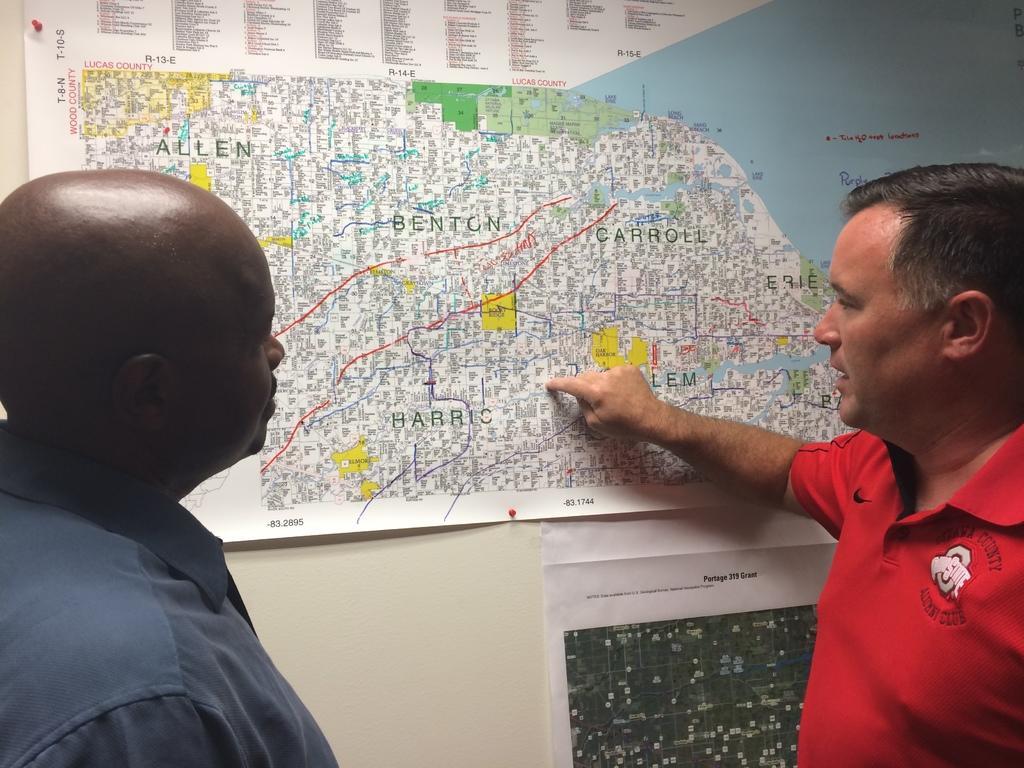Describe this image in one or two sentences. In this image there are two men standing, in the background there is a wall for that wall there is a map. 